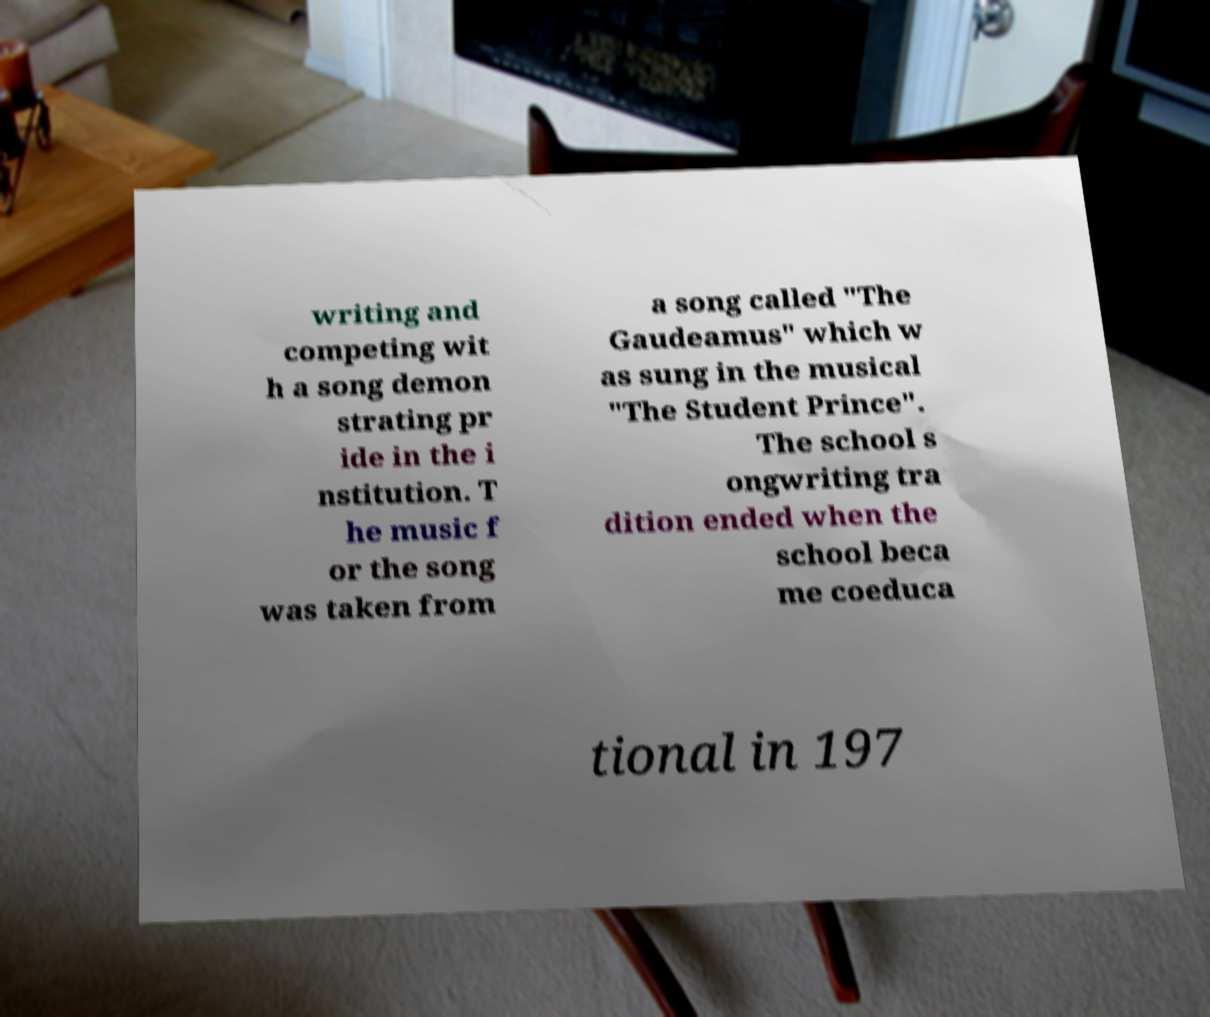For documentation purposes, I need the text within this image transcribed. Could you provide that? writing and competing wit h a song demon strating pr ide in the i nstitution. T he music f or the song was taken from a song called "The Gaudeamus" which w as sung in the musical "The Student Prince". The school s ongwriting tra dition ended when the school beca me coeduca tional in 197 